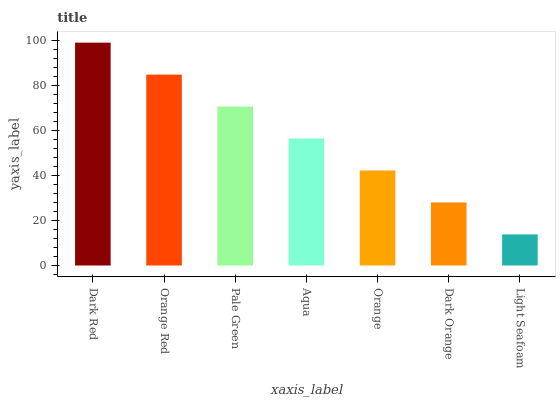Is Light Seafoam the minimum?
Answer yes or no. Yes. Is Dark Red the maximum?
Answer yes or no. Yes. Is Orange Red the minimum?
Answer yes or no. No. Is Orange Red the maximum?
Answer yes or no. No. Is Dark Red greater than Orange Red?
Answer yes or no. Yes. Is Orange Red less than Dark Red?
Answer yes or no. Yes. Is Orange Red greater than Dark Red?
Answer yes or no. No. Is Dark Red less than Orange Red?
Answer yes or no. No. Is Aqua the high median?
Answer yes or no. Yes. Is Aqua the low median?
Answer yes or no. Yes. Is Orange Red the high median?
Answer yes or no. No. Is Orange Red the low median?
Answer yes or no. No. 